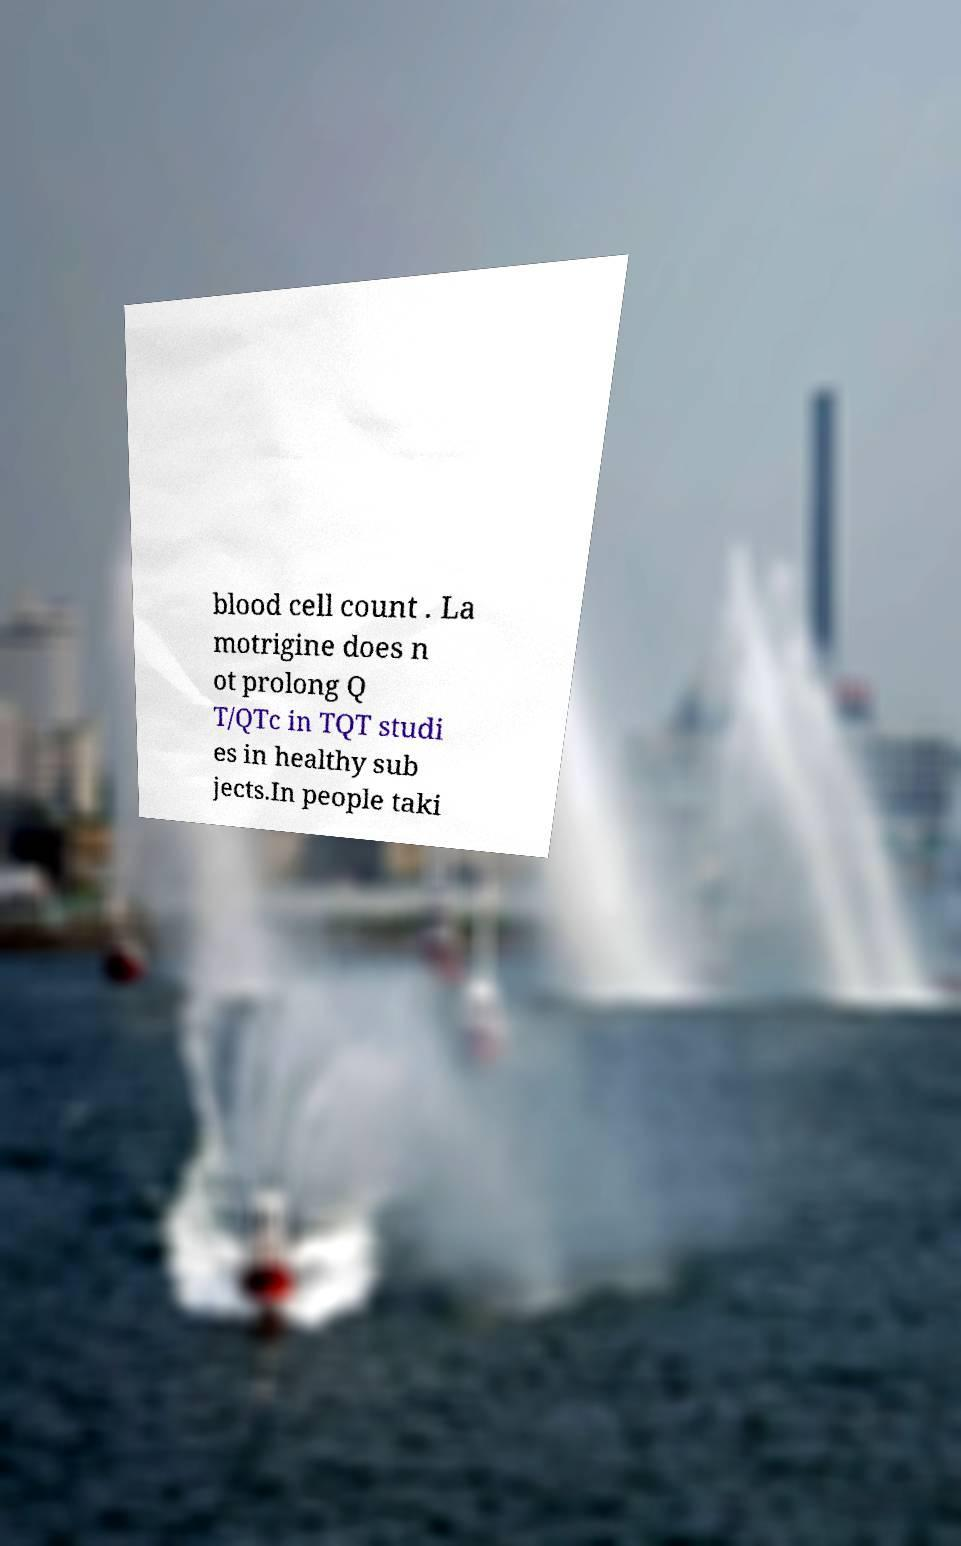Please read and relay the text visible in this image. What does it say? blood cell count . La motrigine does n ot prolong Q T/QTc in TQT studi es in healthy sub jects.In people taki 